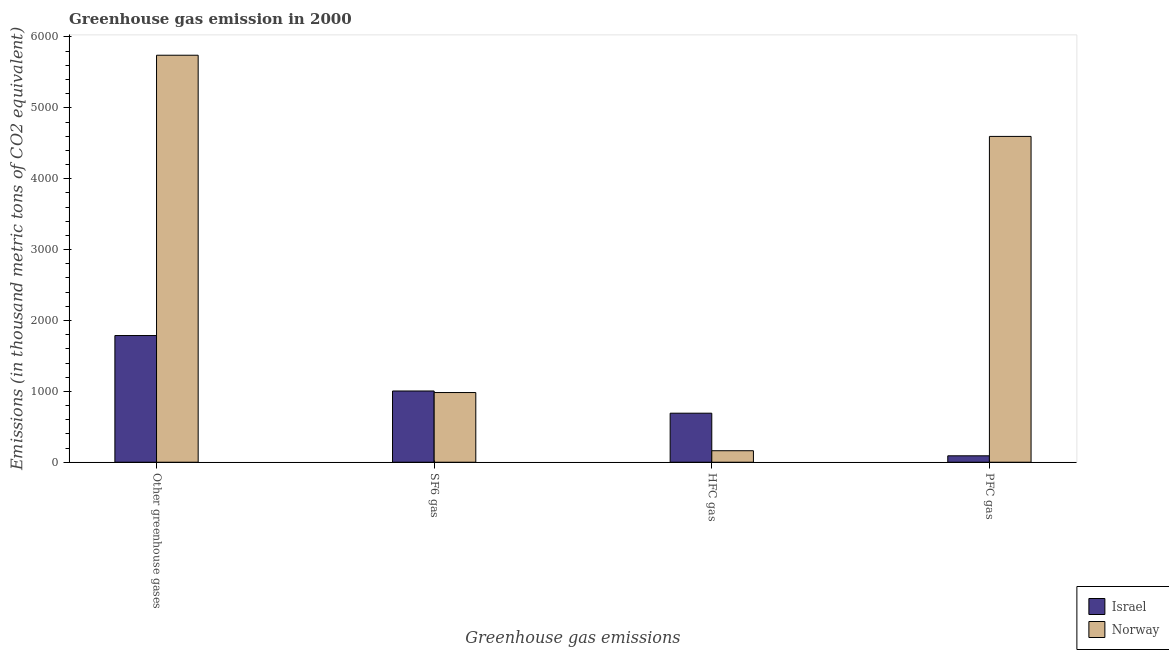How many different coloured bars are there?
Your answer should be compact. 2. How many bars are there on the 4th tick from the left?
Ensure brevity in your answer.  2. How many bars are there on the 4th tick from the right?
Give a very brief answer. 2. What is the label of the 2nd group of bars from the left?
Provide a short and direct response. SF6 gas. What is the emission of hfc gas in Norway?
Provide a succinct answer. 162.3. Across all countries, what is the maximum emission of sf6 gas?
Your answer should be compact. 1005.2. Across all countries, what is the minimum emission of greenhouse gases?
Provide a short and direct response. 1787.6. In which country was the emission of greenhouse gases minimum?
Offer a very short reply. Israel. What is the total emission of hfc gas in the graph?
Your answer should be compact. 854.2. What is the difference between the emission of hfc gas in Israel and that in Norway?
Your answer should be very brief. 529.6. What is the difference between the emission of hfc gas in Norway and the emission of pfc gas in Israel?
Offer a very short reply. 71.8. What is the average emission of hfc gas per country?
Make the answer very short. 427.1. What is the difference between the emission of greenhouse gases and emission of pfc gas in Israel?
Ensure brevity in your answer.  1697.1. What is the ratio of the emission of sf6 gas in Israel to that in Norway?
Make the answer very short. 1.02. Is the emission of pfc gas in Norway less than that in Israel?
Ensure brevity in your answer.  No. Is the difference between the emission of greenhouse gases in Israel and Norway greater than the difference between the emission of pfc gas in Israel and Norway?
Provide a short and direct response. Yes. What is the difference between the highest and the second highest emission of pfc gas?
Provide a short and direct response. 4506.8. What is the difference between the highest and the lowest emission of pfc gas?
Your answer should be very brief. 4506.8. Is it the case that in every country, the sum of the emission of hfc gas and emission of sf6 gas is greater than the sum of emission of greenhouse gases and emission of pfc gas?
Offer a very short reply. No. What does the 1st bar from the left in HFC gas represents?
Your answer should be very brief. Israel. What does the 1st bar from the right in HFC gas represents?
Make the answer very short. Norway. How many bars are there?
Make the answer very short. 8. Are all the bars in the graph horizontal?
Make the answer very short. No. Are the values on the major ticks of Y-axis written in scientific E-notation?
Your answer should be very brief. No. Where does the legend appear in the graph?
Offer a very short reply. Bottom right. How many legend labels are there?
Your response must be concise. 2. What is the title of the graph?
Your answer should be compact. Greenhouse gas emission in 2000. Does "Senegal" appear as one of the legend labels in the graph?
Your answer should be very brief. No. What is the label or title of the X-axis?
Your answer should be very brief. Greenhouse gas emissions. What is the label or title of the Y-axis?
Provide a short and direct response. Emissions (in thousand metric tons of CO2 equivalent). What is the Emissions (in thousand metric tons of CO2 equivalent) of Israel in Other greenhouse gases?
Make the answer very short. 1787.6. What is the Emissions (in thousand metric tons of CO2 equivalent) of Norway in Other greenhouse gases?
Offer a terse response. 5742.8. What is the Emissions (in thousand metric tons of CO2 equivalent) in Israel in SF6 gas?
Offer a very short reply. 1005.2. What is the Emissions (in thousand metric tons of CO2 equivalent) in Norway in SF6 gas?
Make the answer very short. 983.2. What is the Emissions (in thousand metric tons of CO2 equivalent) of Israel in HFC gas?
Offer a terse response. 691.9. What is the Emissions (in thousand metric tons of CO2 equivalent) in Norway in HFC gas?
Offer a terse response. 162.3. What is the Emissions (in thousand metric tons of CO2 equivalent) in Israel in PFC gas?
Provide a succinct answer. 90.5. What is the Emissions (in thousand metric tons of CO2 equivalent) of Norway in PFC gas?
Provide a short and direct response. 4597.3. Across all Greenhouse gas emissions, what is the maximum Emissions (in thousand metric tons of CO2 equivalent) in Israel?
Your answer should be compact. 1787.6. Across all Greenhouse gas emissions, what is the maximum Emissions (in thousand metric tons of CO2 equivalent) of Norway?
Offer a very short reply. 5742.8. Across all Greenhouse gas emissions, what is the minimum Emissions (in thousand metric tons of CO2 equivalent) in Israel?
Your answer should be compact. 90.5. Across all Greenhouse gas emissions, what is the minimum Emissions (in thousand metric tons of CO2 equivalent) of Norway?
Your response must be concise. 162.3. What is the total Emissions (in thousand metric tons of CO2 equivalent) in Israel in the graph?
Your answer should be very brief. 3575.2. What is the total Emissions (in thousand metric tons of CO2 equivalent) in Norway in the graph?
Keep it short and to the point. 1.15e+04. What is the difference between the Emissions (in thousand metric tons of CO2 equivalent) of Israel in Other greenhouse gases and that in SF6 gas?
Make the answer very short. 782.4. What is the difference between the Emissions (in thousand metric tons of CO2 equivalent) of Norway in Other greenhouse gases and that in SF6 gas?
Give a very brief answer. 4759.6. What is the difference between the Emissions (in thousand metric tons of CO2 equivalent) of Israel in Other greenhouse gases and that in HFC gas?
Your answer should be compact. 1095.7. What is the difference between the Emissions (in thousand metric tons of CO2 equivalent) in Norway in Other greenhouse gases and that in HFC gas?
Your answer should be compact. 5580.5. What is the difference between the Emissions (in thousand metric tons of CO2 equivalent) of Israel in Other greenhouse gases and that in PFC gas?
Make the answer very short. 1697.1. What is the difference between the Emissions (in thousand metric tons of CO2 equivalent) of Norway in Other greenhouse gases and that in PFC gas?
Make the answer very short. 1145.5. What is the difference between the Emissions (in thousand metric tons of CO2 equivalent) of Israel in SF6 gas and that in HFC gas?
Provide a succinct answer. 313.3. What is the difference between the Emissions (in thousand metric tons of CO2 equivalent) of Norway in SF6 gas and that in HFC gas?
Your answer should be compact. 820.9. What is the difference between the Emissions (in thousand metric tons of CO2 equivalent) in Israel in SF6 gas and that in PFC gas?
Provide a short and direct response. 914.7. What is the difference between the Emissions (in thousand metric tons of CO2 equivalent) in Norway in SF6 gas and that in PFC gas?
Make the answer very short. -3614.1. What is the difference between the Emissions (in thousand metric tons of CO2 equivalent) in Israel in HFC gas and that in PFC gas?
Your answer should be compact. 601.4. What is the difference between the Emissions (in thousand metric tons of CO2 equivalent) of Norway in HFC gas and that in PFC gas?
Your response must be concise. -4435. What is the difference between the Emissions (in thousand metric tons of CO2 equivalent) of Israel in Other greenhouse gases and the Emissions (in thousand metric tons of CO2 equivalent) of Norway in SF6 gas?
Provide a short and direct response. 804.4. What is the difference between the Emissions (in thousand metric tons of CO2 equivalent) of Israel in Other greenhouse gases and the Emissions (in thousand metric tons of CO2 equivalent) of Norway in HFC gas?
Provide a short and direct response. 1625.3. What is the difference between the Emissions (in thousand metric tons of CO2 equivalent) of Israel in Other greenhouse gases and the Emissions (in thousand metric tons of CO2 equivalent) of Norway in PFC gas?
Your answer should be very brief. -2809.7. What is the difference between the Emissions (in thousand metric tons of CO2 equivalent) in Israel in SF6 gas and the Emissions (in thousand metric tons of CO2 equivalent) in Norway in HFC gas?
Your answer should be very brief. 842.9. What is the difference between the Emissions (in thousand metric tons of CO2 equivalent) in Israel in SF6 gas and the Emissions (in thousand metric tons of CO2 equivalent) in Norway in PFC gas?
Offer a terse response. -3592.1. What is the difference between the Emissions (in thousand metric tons of CO2 equivalent) of Israel in HFC gas and the Emissions (in thousand metric tons of CO2 equivalent) of Norway in PFC gas?
Ensure brevity in your answer.  -3905.4. What is the average Emissions (in thousand metric tons of CO2 equivalent) of Israel per Greenhouse gas emissions?
Provide a succinct answer. 893.8. What is the average Emissions (in thousand metric tons of CO2 equivalent) of Norway per Greenhouse gas emissions?
Make the answer very short. 2871.4. What is the difference between the Emissions (in thousand metric tons of CO2 equivalent) in Israel and Emissions (in thousand metric tons of CO2 equivalent) in Norway in Other greenhouse gases?
Provide a succinct answer. -3955.2. What is the difference between the Emissions (in thousand metric tons of CO2 equivalent) in Israel and Emissions (in thousand metric tons of CO2 equivalent) in Norway in HFC gas?
Ensure brevity in your answer.  529.6. What is the difference between the Emissions (in thousand metric tons of CO2 equivalent) in Israel and Emissions (in thousand metric tons of CO2 equivalent) in Norway in PFC gas?
Your answer should be very brief. -4506.8. What is the ratio of the Emissions (in thousand metric tons of CO2 equivalent) in Israel in Other greenhouse gases to that in SF6 gas?
Ensure brevity in your answer.  1.78. What is the ratio of the Emissions (in thousand metric tons of CO2 equivalent) of Norway in Other greenhouse gases to that in SF6 gas?
Give a very brief answer. 5.84. What is the ratio of the Emissions (in thousand metric tons of CO2 equivalent) of Israel in Other greenhouse gases to that in HFC gas?
Provide a short and direct response. 2.58. What is the ratio of the Emissions (in thousand metric tons of CO2 equivalent) of Norway in Other greenhouse gases to that in HFC gas?
Keep it short and to the point. 35.38. What is the ratio of the Emissions (in thousand metric tons of CO2 equivalent) of Israel in Other greenhouse gases to that in PFC gas?
Offer a terse response. 19.75. What is the ratio of the Emissions (in thousand metric tons of CO2 equivalent) of Norway in Other greenhouse gases to that in PFC gas?
Your response must be concise. 1.25. What is the ratio of the Emissions (in thousand metric tons of CO2 equivalent) of Israel in SF6 gas to that in HFC gas?
Provide a short and direct response. 1.45. What is the ratio of the Emissions (in thousand metric tons of CO2 equivalent) of Norway in SF6 gas to that in HFC gas?
Provide a short and direct response. 6.06. What is the ratio of the Emissions (in thousand metric tons of CO2 equivalent) of Israel in SF6 gas to that in PFC gas?
Your response must be concise. 11.11. What is the ratio of the Emissions (in thousand metric tons of CO2 equivalent) of Norway in SF6 gas to that in PFC gas?
Ensure brevity in your answer.  0.21. What is the ratio of the Emissions (in thousand metric tons of CO2 equivalent) in Israel in HFC gas to that in PFC gas?
Your answer should be very brief. 7.65. What is the ratio of the Emissions (in thousand metric tons of CO2 equivalent) of Norway in HFC gas to that in PFC gas?
Give a very brief answer. 0.04. What is the difference between the highest and the second highest Emissions (in thousand metric tons of CO2 equivalent) in Israel?
Provide a succinct answer. 782.4. What is the difference between the highest and the second highest Emissions (in thousand metric tons of CO2 equivalent) of Norway?
Ensure brevity in your answer.  1145.5. What is the difference between the highest and the lowest Emissions (in thousand metric tons of CO2 equivalent) in Israel?
Give a very brief answer. 1697.1. What is the difference between the highest and the lowest Emissions (in thousand metric tons of CO2 equivalent) of Norway?
Your answer should be compact. 5580.5. 